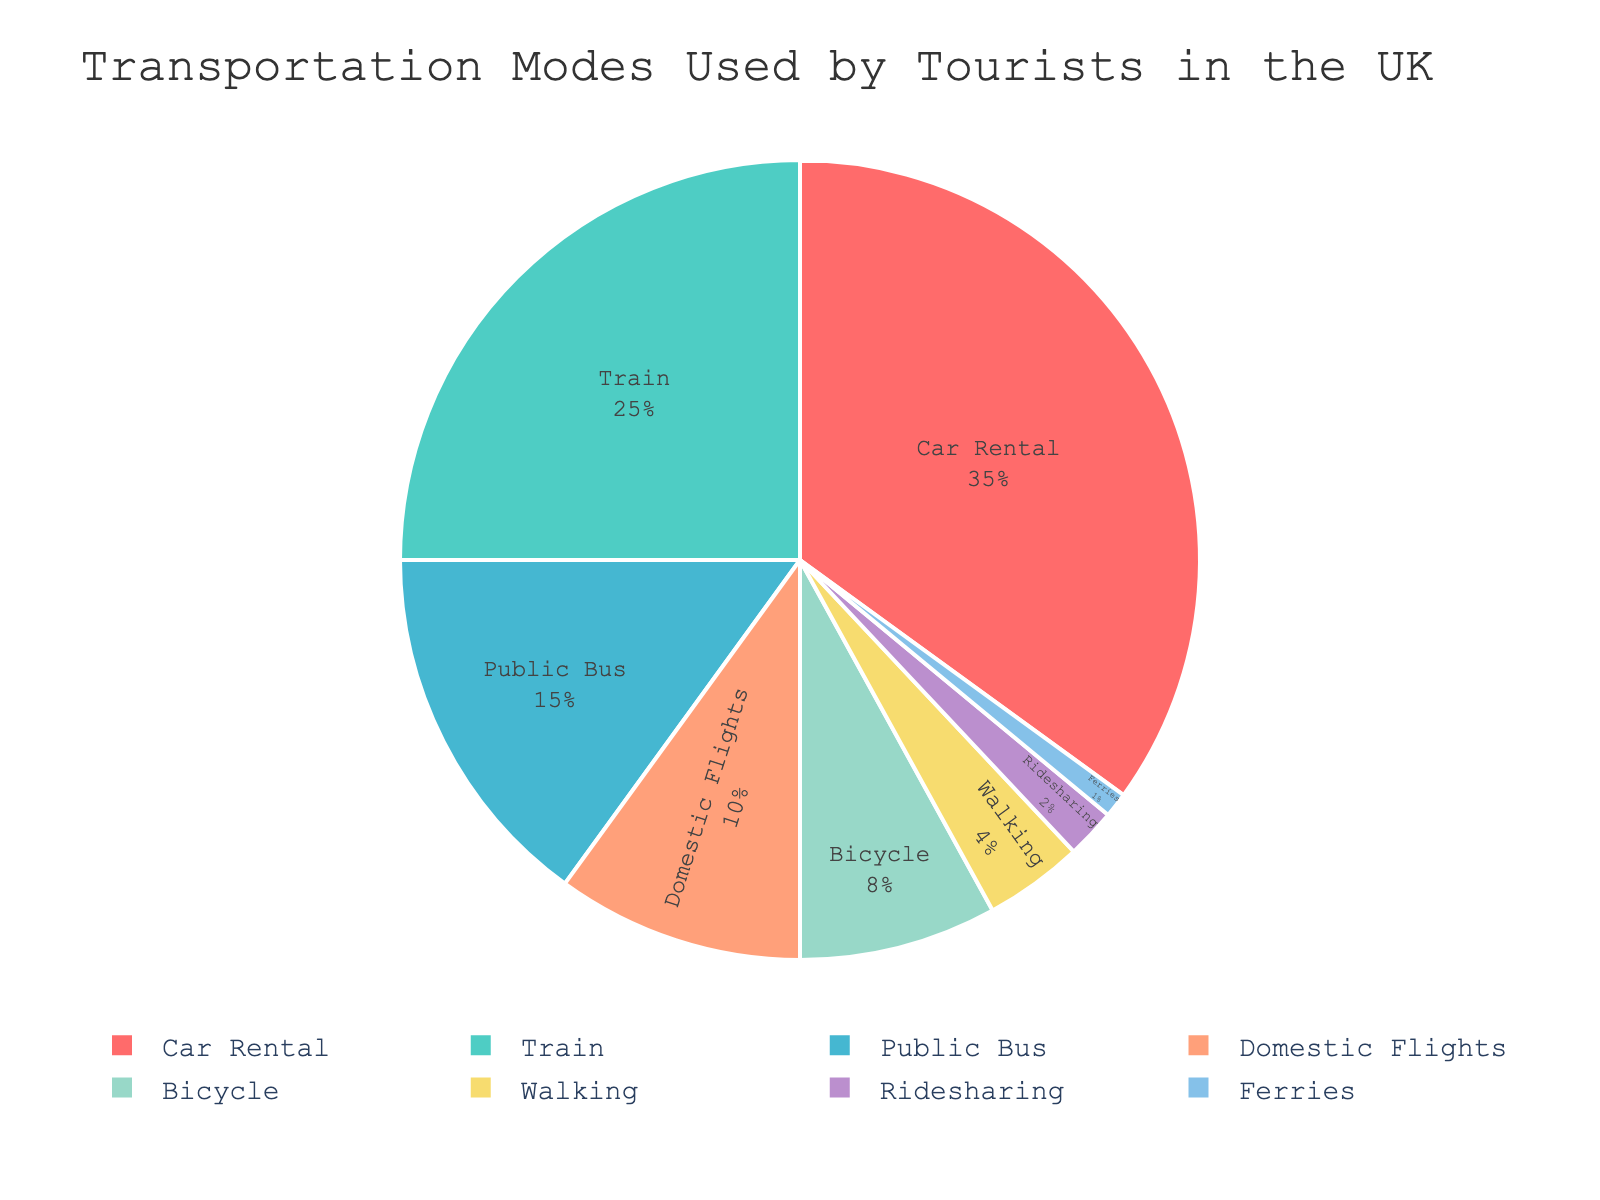What's the most commonly used transportation mode by tourists in the UK? The pie chart displays the percentages of different transportation modes. The largest segment, which corresponds to 35%, represents Car Rental.
Answer: Car Rental Which transportation mode is used the least by tourists in the UK? The pie chart shows that the smallest segment, representing 1%, corresponds to Ferries.
Answer: Ferries What is the combined percentage of tourists using Train and Public Bus? According to the pie chart, Train usage is 25% and Public Bus usage is 15%. Therefore, the combined percentage is 25 + 15 = 40%.
Answer: 40% How does the percentage of tourists using Domestic Flights compare to those using Bicycle? The pie chart indicates that Domestic Flights are used by 10% of tourists, whereas Bicycle is used by 8%. Therefore, Domestic Flights usage is 2% more than Bicycle usage.
Answer: 2% What transportation mode is represented by the green color, and what is its percentage? The pie chart uses a custom color palette, where green represents the Train category. The corresponding percentage for Train is 25%.
Answer: Train, 25% How much more popular is Car Rental compared to Walking? Car Rental is used by 35% of tourists, and Walking is used by 4%. The difference between them is 35 - 4 = 31%.
Answer: 31% What is the total percentage of tourists using active transportation modes (Bicycle and Walking)? The pie chart indicates that Bicycle is used by 8% and Walking by 4%. Therefore, the total percentage of tourists using active transportation modes is 8 + 4 = 12%.
Answer: 12% Which transportation mode has a similar percentage as Public Bus? The pie chart shows that Public Bus is used by 15% of tourists. The closest percentage to Public Bus is Domestic Flights, which is used by 10% of tourists.
Answer: Domestic Flights Is Ridesharing more popular than Ferries? Ridesharing has a percentage of 2%, while Ferries have a percentage of 1%. Therefore, Ridesharing is more popular than Ferries.
Answer: Yes What is the combined percentage of the three least popular modes of transportation? The three least popular modes are Ferries (1%), Ridesharing (2%), and Walking (4%). Their combined percentage is 1 + 2 + 4 = 7%.
Answer: 7% 